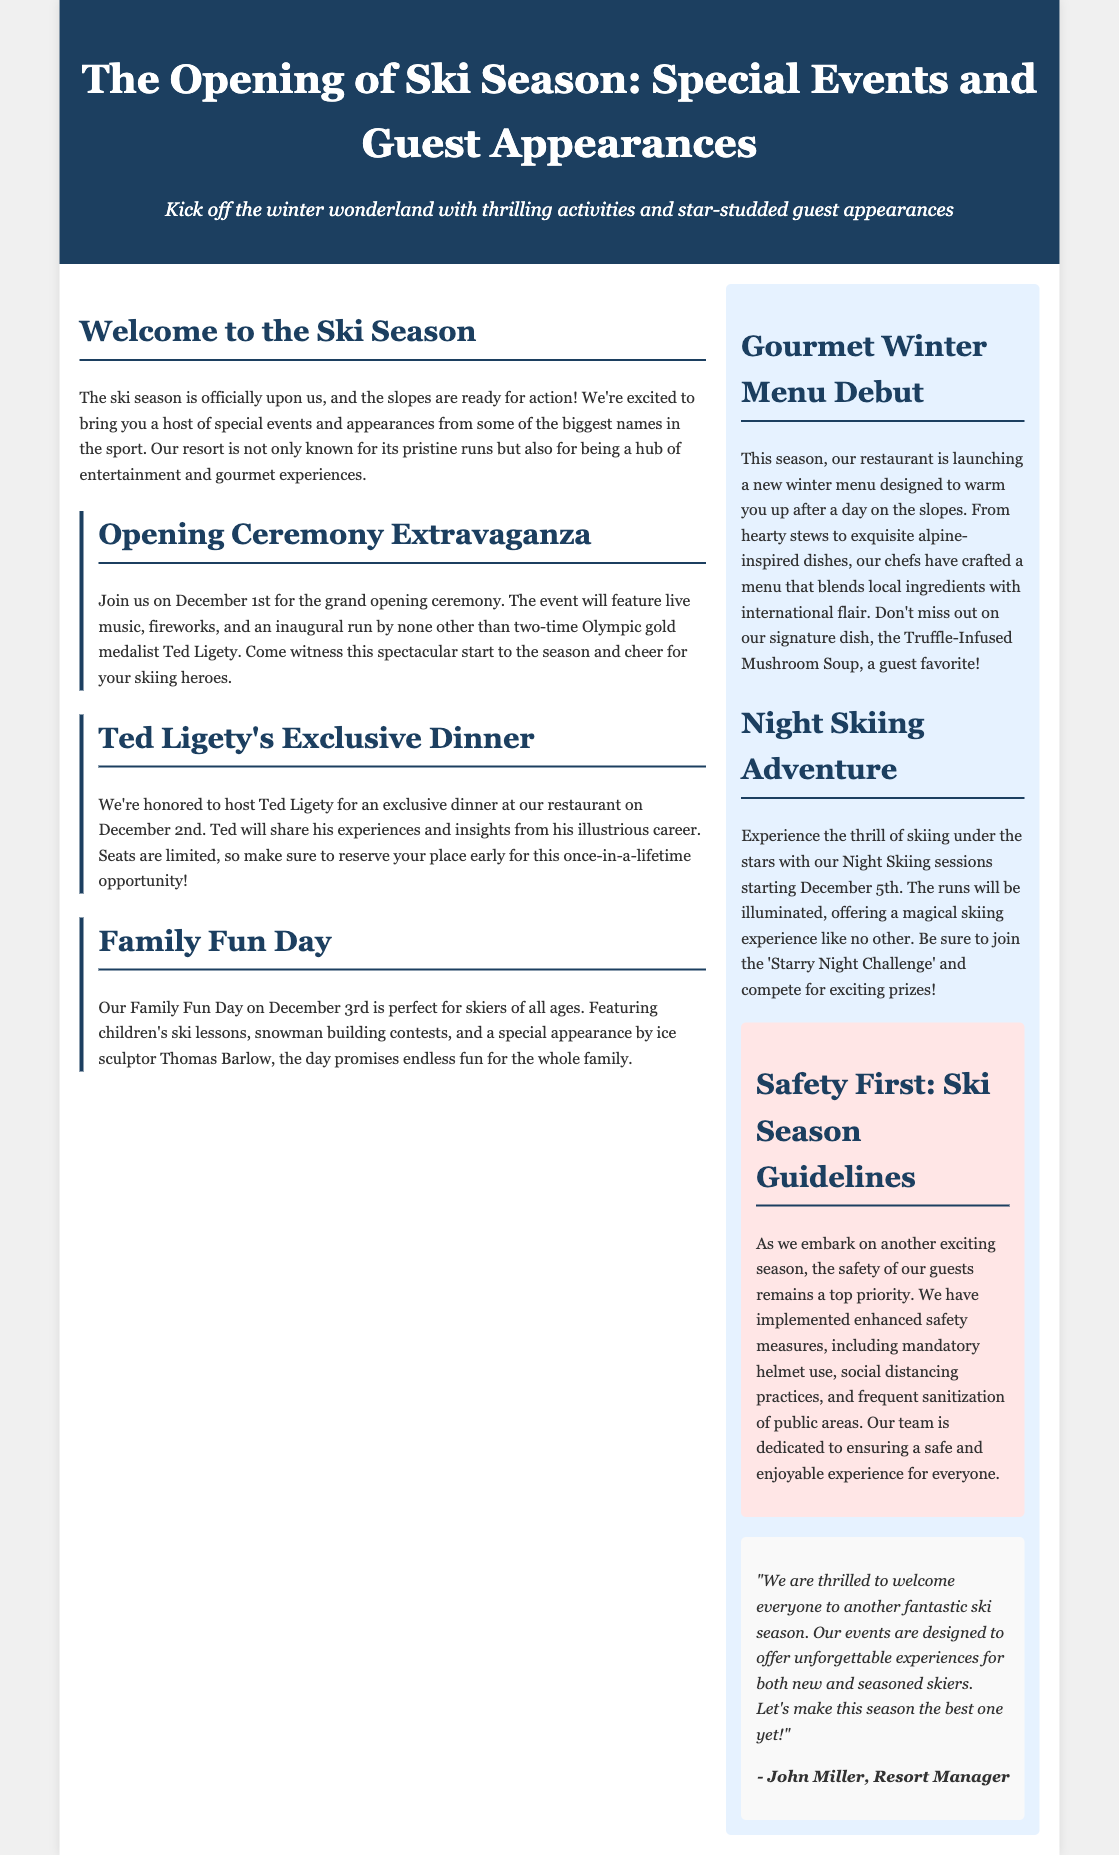What is the date of the opening ceremony? The date for the grand opening ceremony is mentioned in the document.
Answer: December 1st Who is the special guest for the exclusive dinner? The document specifies the name of the guest who will attend the exclusive dinner.
Answer: Ted Ligety What will be featured during the Family Fun Day? The document lists several activities that will take place during Family Fun Day.
Answer: Children’s ski lessons, snowman building contests, and a special appearance by ice sculptor Thomas Barlow What is the name of the signature dish at the restaurant? The document highlights a specific dish that is a guest favorite.
Answer: Truffle-Infused Mushroom Soup What safety measure is mentioned in the document? The document outlines specific safety measures to be followed during the ski season.
Answer: Mandatory helmet use What type of skiing experience is offered starting December 5th? This part of the document introduces a new skiing experience available on a specific date.
Answer: Night skiing What is included in the opening ceremony? The document describes elements that will be included in the opening ceremony.
Answer: Live music, fireworks, and an inaugural run by Ted Ligety How is the restaurant's new menu designed? The document elaborates on the characteristics of the new winter menu.
Answer: To warm you up after a day on the slopes What is the theme of John Miller's quote? The quote from John Miller expresses the sentiment towards the ski season events in the document.
Answer: Excitement for the ski season 